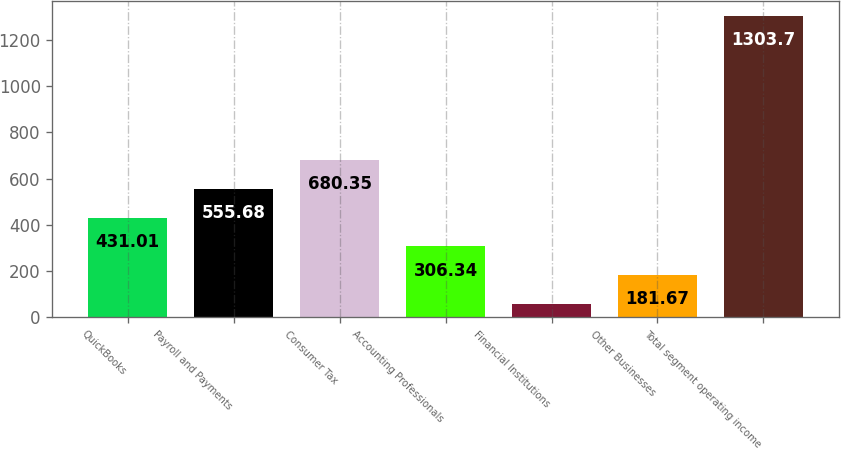<chart> <loc_0><loc_0><loc_500><loc_500><bar_chart><fcel>QuickBooks<fcel>Payroll and Payments<fcel>Consumer Tax<fcel>Accounting Professionals<fcel>Financial Institutions<fcel>Other Businesses<fcel>Total segment operating income<nl><fcel>431.01<fcel>555.68<fcel>680.35<fcel>306.34<fcel>57<fcel>181.67<fcel>1303.7<nl></chart> 